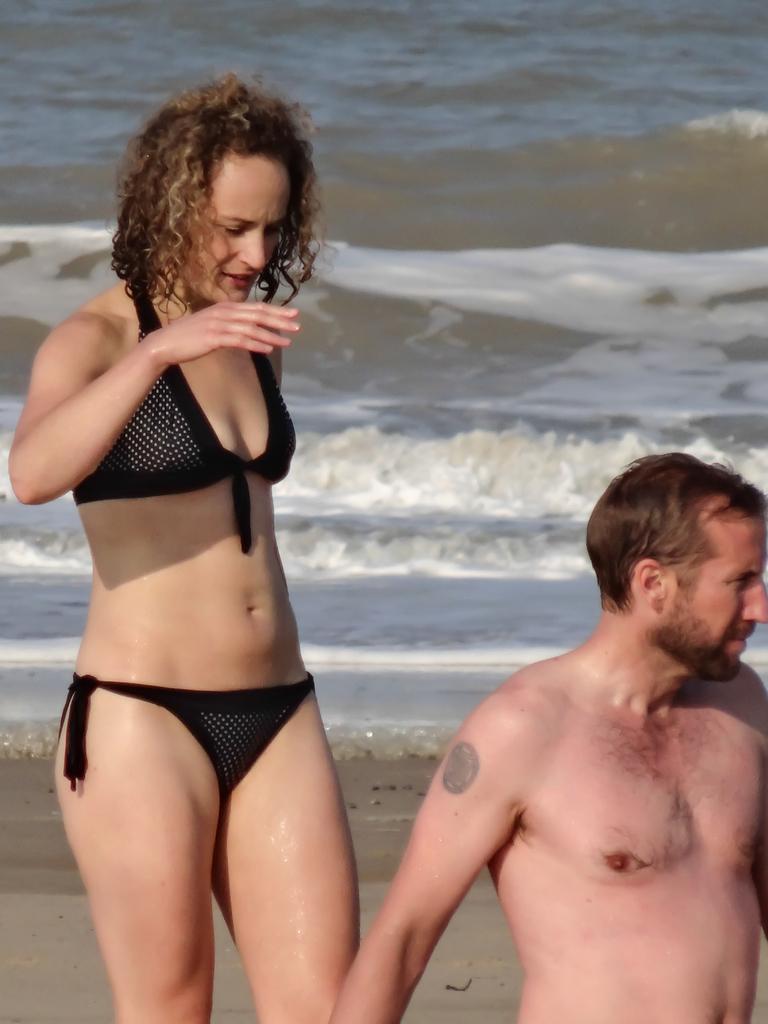Can you describe this image briefly? In this image there are two persons, there is a person truncated towards the right of the image, there are person truncated towards the bottom of the image, there is sand, there is a sea truncated. 